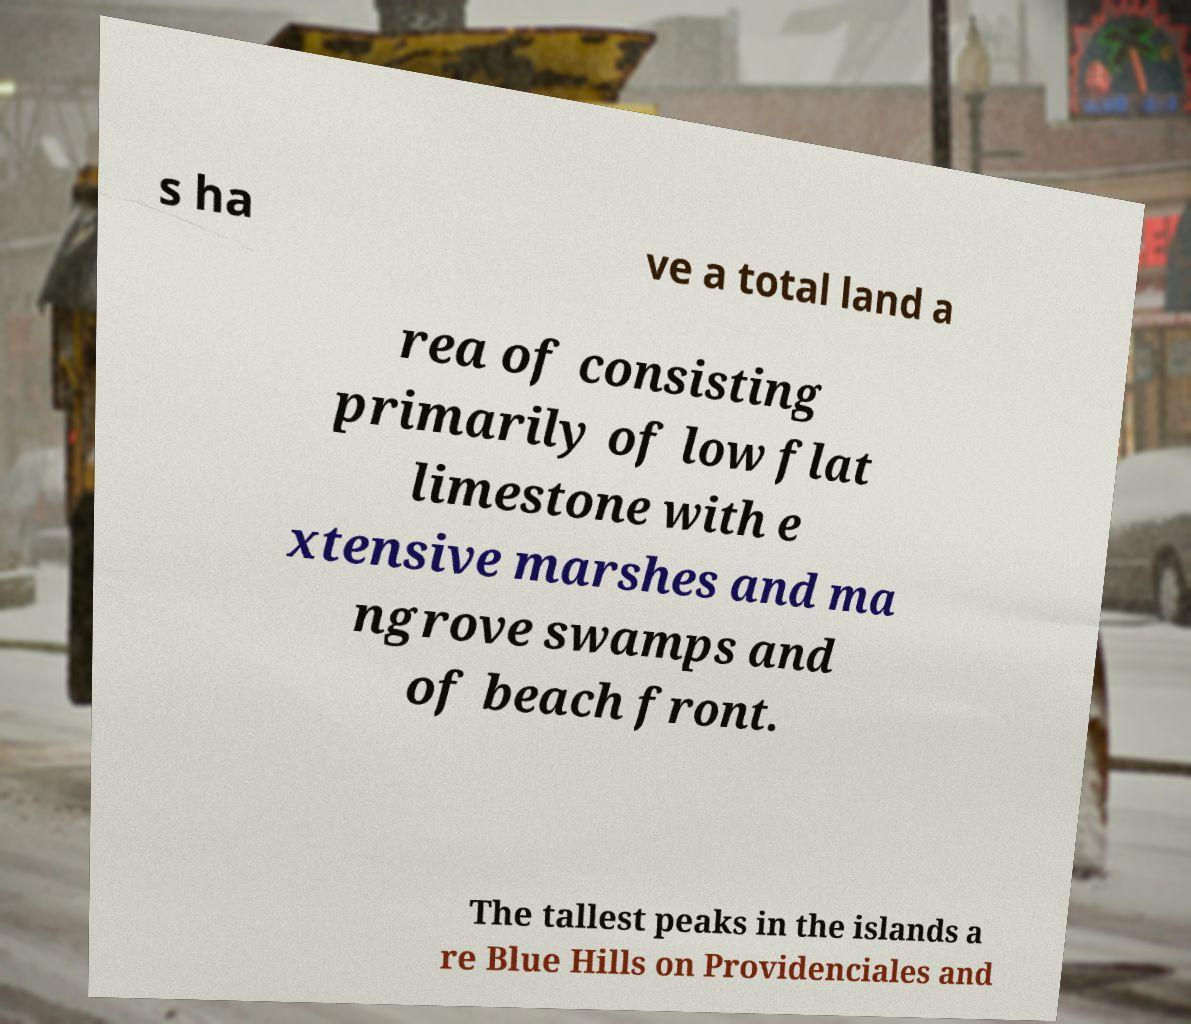Could you assist in decoding the text presented in this image and type it out clearly? s ha ve a total land a rea of consisting primarily of low flat limestone with e xtensive marshes and ma ngrove swamps and of beach front. The tallest peaks in the islands a re Blue Hills on Providenciales and 